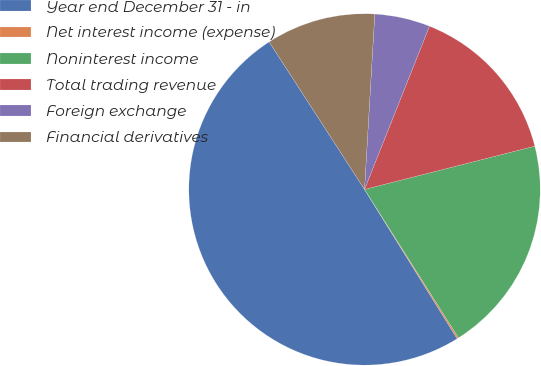Convert chart to OTSL. <chart><loc_0><loc_0><loc_500><loc_500><pie_chart><fcel>Year end December 31 - in<fcel>Net interest income (expense)<fcel>Noninterest income<fcel>Total trading revenue<fcel>Foreign exchange<fcel>Financial derivatives<nl><fcel>49.7%<fcel>0.15%<fcel>19.97%<fcel>15.01%<fcel>5.1%<fcel>10.06%<nl></chart> 